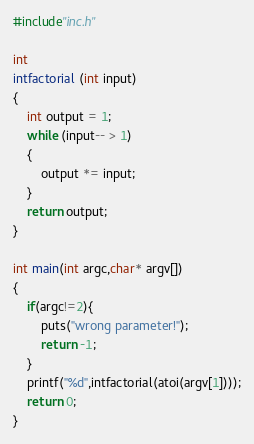Convert code to text. <code><loc_0><loc_0><loc_500><loc_500><_C_>#include"inc.h"

int
intfactorial (int input)
{
    int output = 1;
    while (input-- > 1)
    {
        output *= input;
    }
    return output;
}

int main(int argc,char* argv[])
{
    if(argc!=2){
        puts("wrong parameter!");
        return -1;
    }
    printf("%d",intfactorial(atoi(argv[1])));
    return 0;
}</code> 